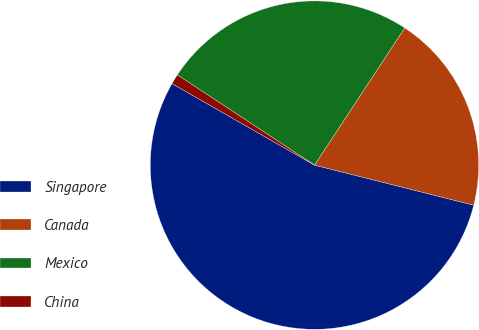Convert chart to OTSL. <chart><loc_0><loc_0><loc_500><loc_500><pie_chart><fcel>Singapore<fcel>Canada<fcel>Mexico<fcel>China<nl><fcel>54.35%<fcel>19.67%<fcel>25.0%<fcel>0.99%<nl></chart> 